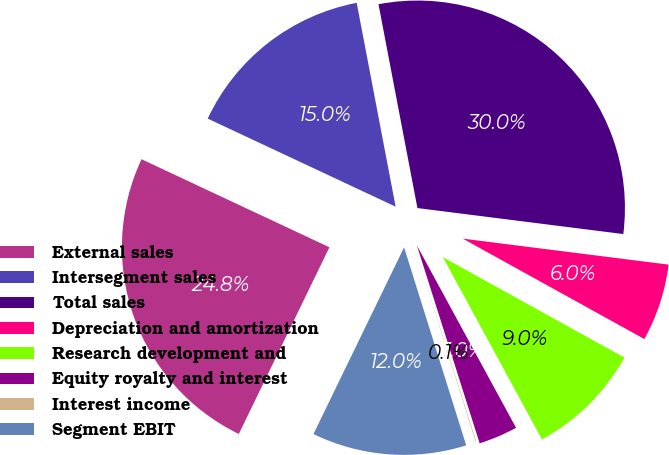Convert chart. <chart><loc_0><loc_0><loc_500><loc_500><pie_chart><fcel>External sales<fcel>Intersegment sales<fcel>Total sales<fcel>Depreciation and amortization<fcel>Research development and<fcel>Equity royalty and interest<fcel>Interest income<fcel>Segment EBIT<nl><fcel>24.78%<fcel>15.02%<fcel>30.0%<fcel>6.04%<fcel>9.03%<fcel>3.04%<fcel>0.05%<fcel>12.03%<nl></chart> 